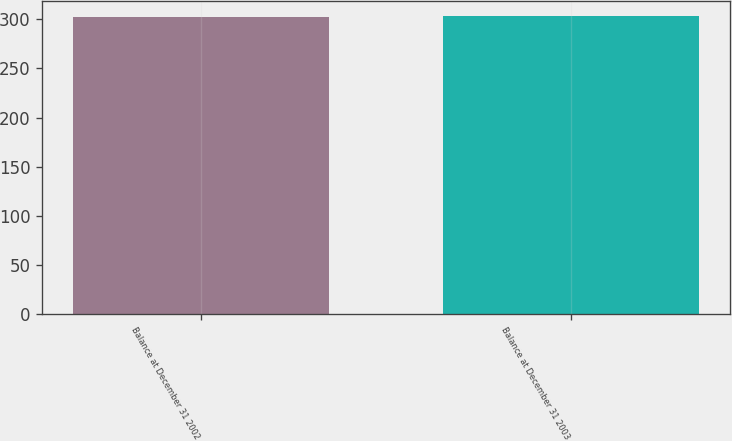Convert chart to OTSL. <chart><loc_0><loc_0><loc_500><loc_500><bar_chart><fcel>Balance at December 31 2002<fcel>Balance at December 31 2003<nl><fcel>302.4<fcel>303.8<nl></chart> 